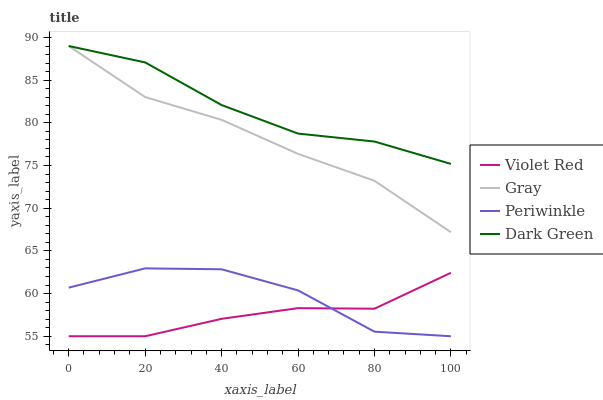Does Periwinkle have the minimum area under the curve?
Answer yes or no. No. Does Periwinkle have the maximum area under the curve?
Answer yes or no. No. Is Violet Red the smoothest?
Answer yes or no. No. Is Violet Red the roughest?
Answer yes or no. No. Does Dark Green have the lowest value?
Answer yes or no. No. Does Periwinkle have the highest value?
Answer yes or no. No. Is Violet Red less than Gray?
Answer yes or no. Yes. Is Dark Green greater than Violet Red?
Answer yes or no. Yes. Does Violet Red intersect Gray?
Answer yes or no. No. 